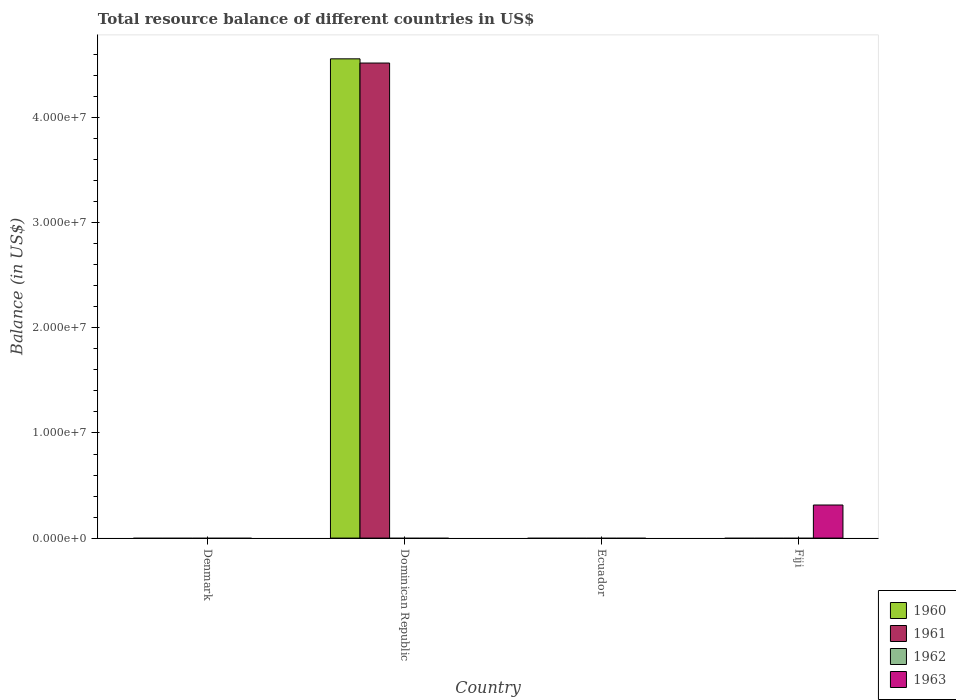What is the label of the 1st group of bars from the left?
Keep it short and to the point. Denmark. In how many cases, is the number of bars for a given country not equal to the number of legend labels?
Your answer should be compact. 4. Across all countries, what is the maximum total resource balance in 1961?
Your answer should be very brief. 4.52e+07. Across all countries, what is the minimum total resource balance in 1961?
Offer a very short reply. 0. In which country was the total resource balance in 1961 maximum?
Your answer should be very brief. Dominican Republic. What is the total total resource balance in 1961 in the graph?
Keep it short and to the point. 4.52e+07. What is the difference between the total resource balance in 1960 in Dominican Republic and the total resource balance in 1962 in Fiji?
Your answer should be compact. 4.56e+07. What is the average total resource balance in 1960 per country?
Offer a terse response. 1.14e+07. What is the difference between the highest and the lowest total resource balance in 1961?
Your response must be concise. 4.52e+07. In how many countries, is the total resource balance in 1963 greater than the average total resource balance in 1963 taken over all countries?
Ensure brevity in your answer.  1. Is it the case that in every country, the sum of the total resource balance in 1963 and total resource balance in 1962 is greater than the sum of total resource balance in 1960 and total resource balance in 1961?
Make the answer very short. No. Is it the case that in every country, the sum of the total resource balance in 1961 and total resource balance in 1960 is greater than the total resource balance in 1962?
Keep it short and to the point. No. What is the difference between two consecutive major ticks on the Y-axis?
Your answer should be compact. 1.00e+07. Does the graph contain any zero values?
Your answer should be compact. Yes. How are the legend labels stacked?
Offer a very short reply. Vertical. What is the title of the graph?
Provide a short and direct response. Total resource balance of different countries in US$. What is the label or title of the Y-axis?
Provide a succinct answer. Balance (in US$). What is the Balance (in US$) in 1961 in Denmark?
Your answer should be compact. 0. What is the Balance (in US$) of 1962 in Denmark?
Give a very brief answer. 0. What is the Balance (in US$) in 1960 in Dominican Republic?
Give a very brief answer. 4.56e+07. What is the Balance (in US$) of 1961 in Dominican Republic?
Keep it short and to the point. 4.52e+07. What is the Balance (in US$) in 1962 in Dominican Republic?
Keep it short and to the point. 0. What is the Balance (in US$) in 1961 in Ecuador?
Make the answer very short. 0. What is the Balance (in US$) in 1962 in Ecuador?
Your answer should be compact. 0. What is the Balance (in US$) in 1963 in Ecuador?
Offer a very short reply. 0. What is the Balance (in US$) of 1960 in Fiji?
Ensure brevity in your answer.  0. What is the Balance (in US$) of 1962 in Fiji?
Keep it short and to the point. 0. What is the Balance (in US$) of 1963 in Fiji?
Offer a terse response. 3.15e+06. Across all countries, what is the maximum Balance (in US$) of 1960?
Ensure brevity in your answer.  4.56e+07. Across all countries, what is the maximum Balance (in US$) in 1961?
Your answer should be compact. 4.52e+07. Across all countries, what is the maximum Balance (in US$) of 1963?
Provide a succinct answer. 3.15e+06. Across all countries, what is the minimum Balance (in US$) of 1963?
Provide a succinct answer. 0. What is the total Balance (in US$) of 1960 in the graph?
Keep it short and to the point. 4.56e+07. What is the total Balance (in US$) in 1961 in the graph?
Give a very brief answer. 4.52e+07. What is the total Balance (in US$) in 1962 in the graph?
Provide a succinct answer. 0. What is the total Balance (in US$) in 1963 in the graph?
Your answer should be compact. 3.15e+06. What is the difference between the Balance (in US$) of 1960 in Dominican Republic and the Balance (in US$) of 1963 in Fiji?
Provide a succinct answer. 4.25e+07. What is the difference between the Balance (in US$) in 1961 in Dominican Republic and the Balance (in US$) in 1963 in Fiji?
Provide a short and direct response. 4.21e+07. What is the average Balance (in US$) of 1960 per country?
Your answer should be compact. 1.14e+07. What is the average Balance (in US$) in 1961 per country?
Provide a succinct answer. 1.13e+07. What is the average Balance (in US$) of 1963 per country?
Keep it short and to the point. 7.87e+05. What is the difference between the highest and the lowest Balance (in US$) of 1960?
Provide a short and direct response. 4.56e+07. What is the difference between the highest and the lowest Balance (in US$) in 1961?
Your response must be concise. 4.52e+07. What is the difference between the highest and the lowest Balance (in US$) in 1963?
Offer a terse response. 3.15e+06. 